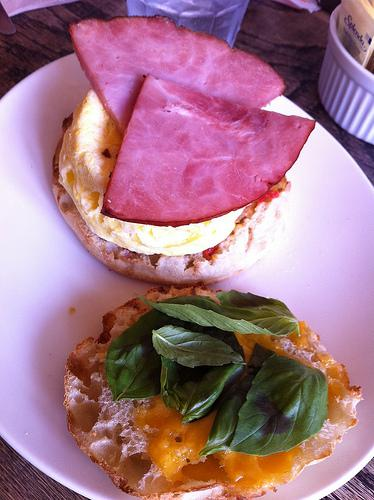Question: how many leaves are there?
Choices:
A. 12.
B. 13.
C. 7.
D. 5.
Answer with the letter. Answer: C Question: how many pieces of bread are there?
Choices:
A. 12.
B. 13.
C. 2.
D. 5.
Answer with the letter. Answer: C Question: what is in the picture?
Choices:
A. Water.
B. Cocktails.
C. Serving platters.
D. Food.
Answer with the letter. Answer: D Question: what color is the cheese?
Choices:
A. Yellow.
B. Orange.
C. White.
D. Light brown.
Answer with the letter. Answer: A 